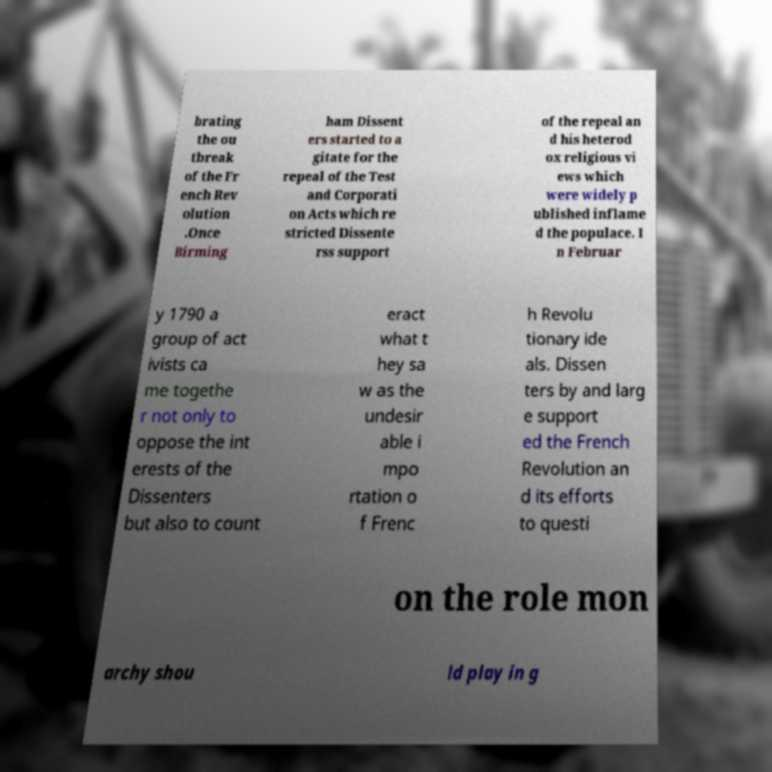There's text embedded in this image that I need extracted. Can you transcribe it verbatim? brating the ou tbreak of the Fr ench Rev olution .Once Birming ham Dissent ers started to a gitate for the repeal of the Test and Corporati on Acts which re stricted Dissente rss support of the repeal an d his heterod ox religious vi ews which were widely p ublished inflame d the populace. I n Februar y 1790 a group of act ivists ca me togethe r not only to oppose the int erests of the Dissenters but also to count eract what t hey sa w as the undesir able i mpo rtation o f Frenc h Revolu tionary ide als. Dissen ters by and larg e support ed the French Revolution an d its efforts to questi on the role mon archy shou ld play in g 